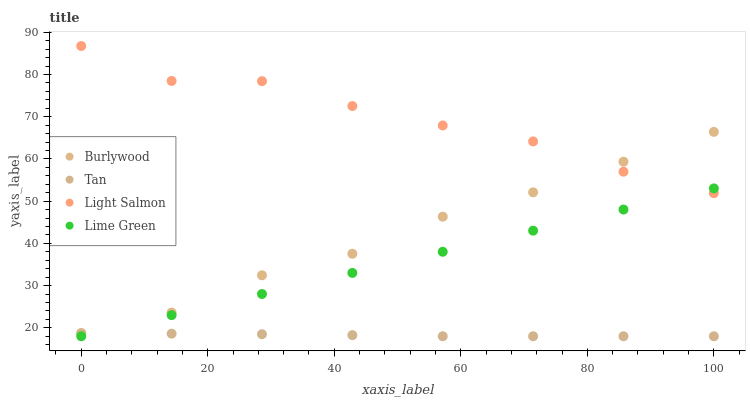Does Tan have the minimum area under the curve?
Answer yes or no. Yes. Does Light Salmon have the maximum area under the curve?
Answer yes or no. Yes. Does Lime Green have the minimum area under the curve?
Answer yes or no. No. Does Lime Green have the maximum area under the curve?
Answer yes or no. No. Is Lime Green the smoothest?
Answer yes or no. Yes. Is Light Salmon the roughest?
Answer yes or no. Yes. Is Tan the smoothest?
Answer yes or no. No. Is Tan the roughest?
Answer yes or no. No. Does Tan have the lowest value?
Answer yes or no. Yes. Does Light Salmon have the lowest value?
Answer yes or no. No. Does Light Salmon have the highest value?
Answer yes or no. Yes. Does Lime Green have the highest value?
Answer yes or no. No. Is Lime Green less than Burlywood?
Answer yes or no. Yes. Is Light Salmon greater than Tan?
Answer yes or no. Yes. Does Light Salmon intersect Lime Green?
Answer yes or no. Yes. Is Light Salmon less than Lime Green?
Answer yes or no. No. Is Light Salmon greater than Lime Green?
Answer yes or no. No. Does Lime Green intersect Burlywood?
Answer yes or no. No. 